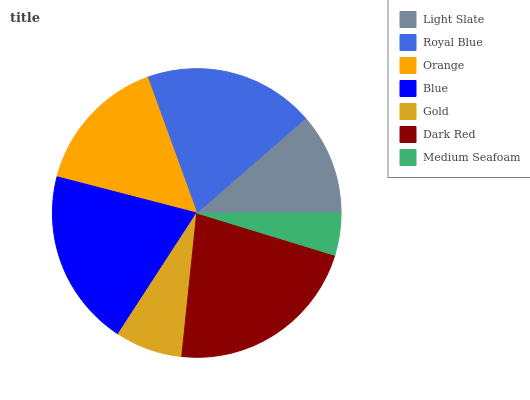Is Medium Seafoam the minimum?
Answer yes or no. Yes. Is Dark Red the maximum?
Answer yes or no. Yes. Is Royal Blue the minimum?
Answer yes or no. No. Is Royal Blue the maximum?
Answer yes or no. No. Is Royal Blue greater than Light Slate?
Answer yes or no. Yes. Is Light Slate less than Royal Blue?
Answer yes or no. Yes. Is Light Slate greater than Royal Blue?
Answer yes or no. No. Is Royal Blue less than Light Slate?
Answer yes or no. No. Is Orange the high median?
Answer yes or no. Yes. Is Orange the low median?
Answer yes or no. Yes. Is Gold the high median?
Answer yes or no. No. Is Dark Red the low median?
Answer yes or no. No. 